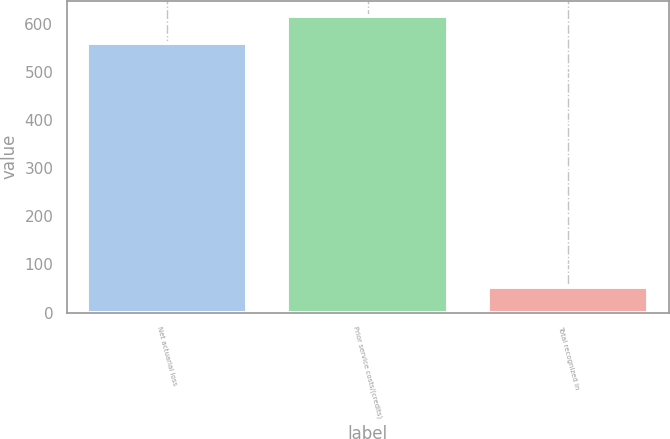<chart> <loc_0><loc_0><loc_500><loc_500><bar_chart><fcel>Net actuarial loss<fcel>Prior service costs/(credits)<fcel>Total recognized in<nl><fcel>561<fcel>617.1<fcel>53<nl></chart> 